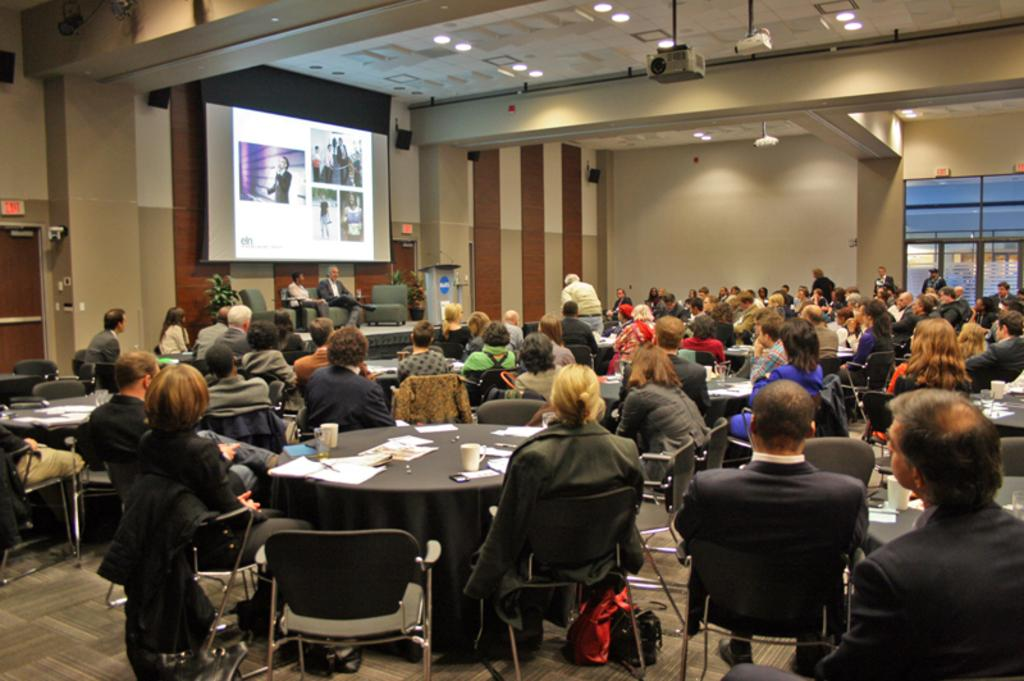How many people are in the image? There is a group of persons in the image. What are the persons in the image doing? The persons are sitting in a room. What equipment is present in the room? There is a projector and a projector screen in the image. What can be seen in the room besides the persons and equipment? There are lights visible in the image. What type of stone is being used as bait for the judge in the image? There is no stone, bait, or judge present in the image. 